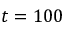Convert formula to latex. <formula><loc_0><loc_0><loc_500><loc_500>t = 1 0 0</formula> 